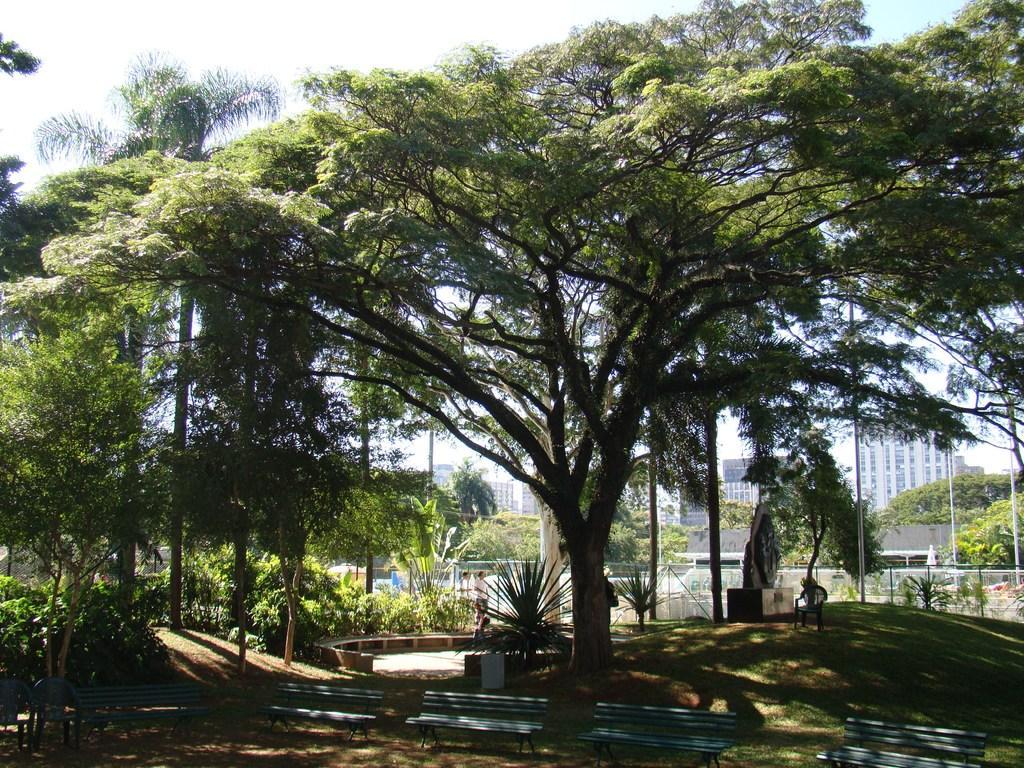Can you describe this image briefly? In this picture we can see benches at the bottom, there are some trees, plants, grass and fencing in the middle, in the background there are some buildings and poles, we can see the sky at the top of the picture. 